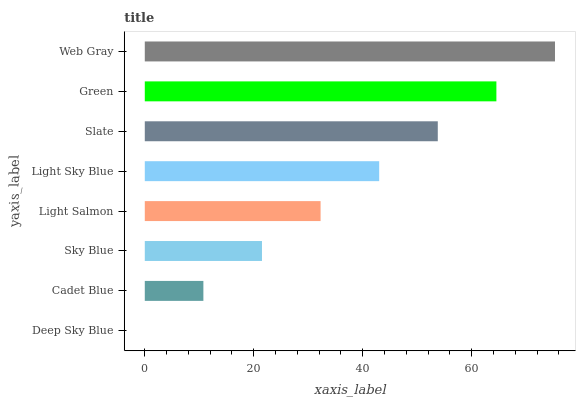Is Deep Sky Blue the minimum?
Answer yes or no. Yes. Is Web Gray the maximum?
Answer yes or no. Yes. Is Cadet Blue the minimum?
Answer yes or no. No. Is Cadet Blue the maximum?
Answer yes or no. No. Is Cadet Blue greater than Deep Sky Blue?
Answer yes or no. Yes. Is Deep Sky Blue less than Cadet Blue?
Answer yes or no. Yes. Is Deep Sky Blue greater than Cadet Blue?
Answer yes or no. No. Is Cadet Blue less than Deep Sky Blue?
Answer yes or no. No. Is Light Sky Blue the high median?
Answer yes or no. Yes. Is Light Salmon the low median?
Answer yes or no. Yes. Is Deep Sky Blue the high median?
Answer yes or no. No. Is Sky Blue the low median?
Answer yes or no. No. 